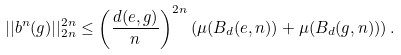Convert formula to latex. <formula><loc_0><loc_0><loc_500><loc_500>| | b ^ { n } ( g ) | | ^ { 2 n } _ { 2 n } \leq \left ( \frac { d ( e , g ) } { n } \right ) ^ { 2 n } \left ( \mu ( B _ { d } ( e , n ) ) + \mu ( B _ { d } ( g , n ) ) \right ) .</formula> 